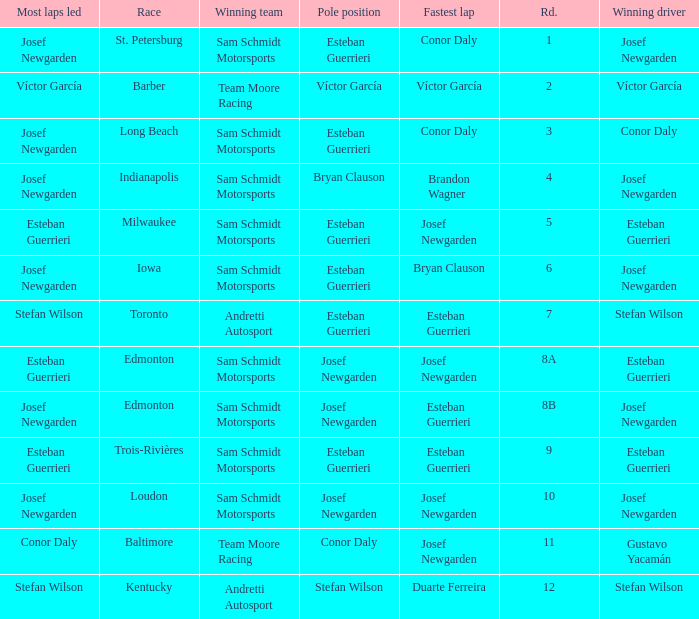Who had the fastest lap(s) when stefan wilson had the pole? Duarte Ferreira. 